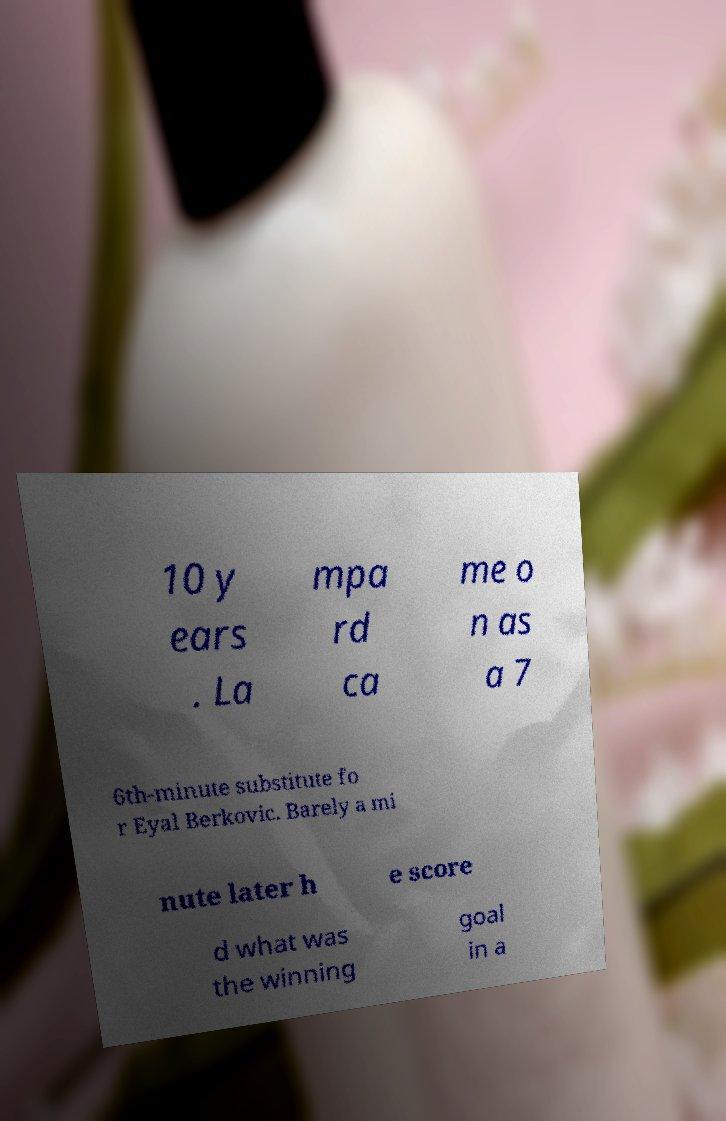Please identify and transcribe the text found in this image. 10 y ears . La mpa rd ca me o n as a 7 6th-minute substitute fo r Eyal Berkovic. Barely a mi nute later h e score d what was the winning goal in a 